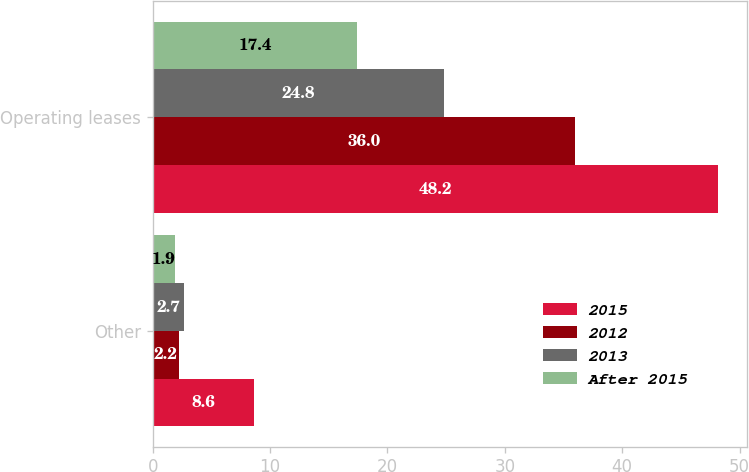Convert chart. <chart><loc_0><loc_0><loc_500><loc_500><stacked_bar_chart><ecel><fcel>Other<fcel>Operating leases<nl><fcel>2015<fcel>8.6<fcel>48.2<nl><fcel>2012<fcel>2.2<fcel>36<nl><fcel>2013<fcel>2.7<fcel>24.8<nl><fcel>After 2015<fcel>1.9<fcel>17.4<nl></chart> 